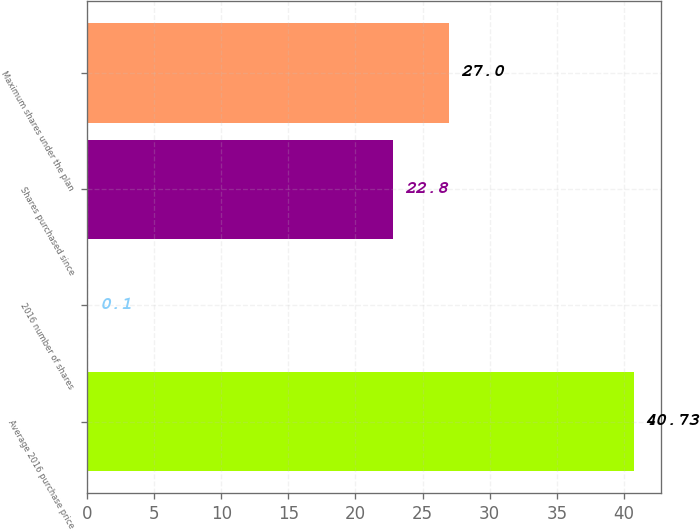<chart> <loc_0><loc_0><loc_500><loc_500><bar_chart><fcel>Average 2016 purchase price<fcel>2016 number of shares<fcel>Shares purchased since<fcel>Maximum shares under the plan<nl><fcel>40.73<fcel>0.1<fcel>22.8<fcel>27<nl></chart> 